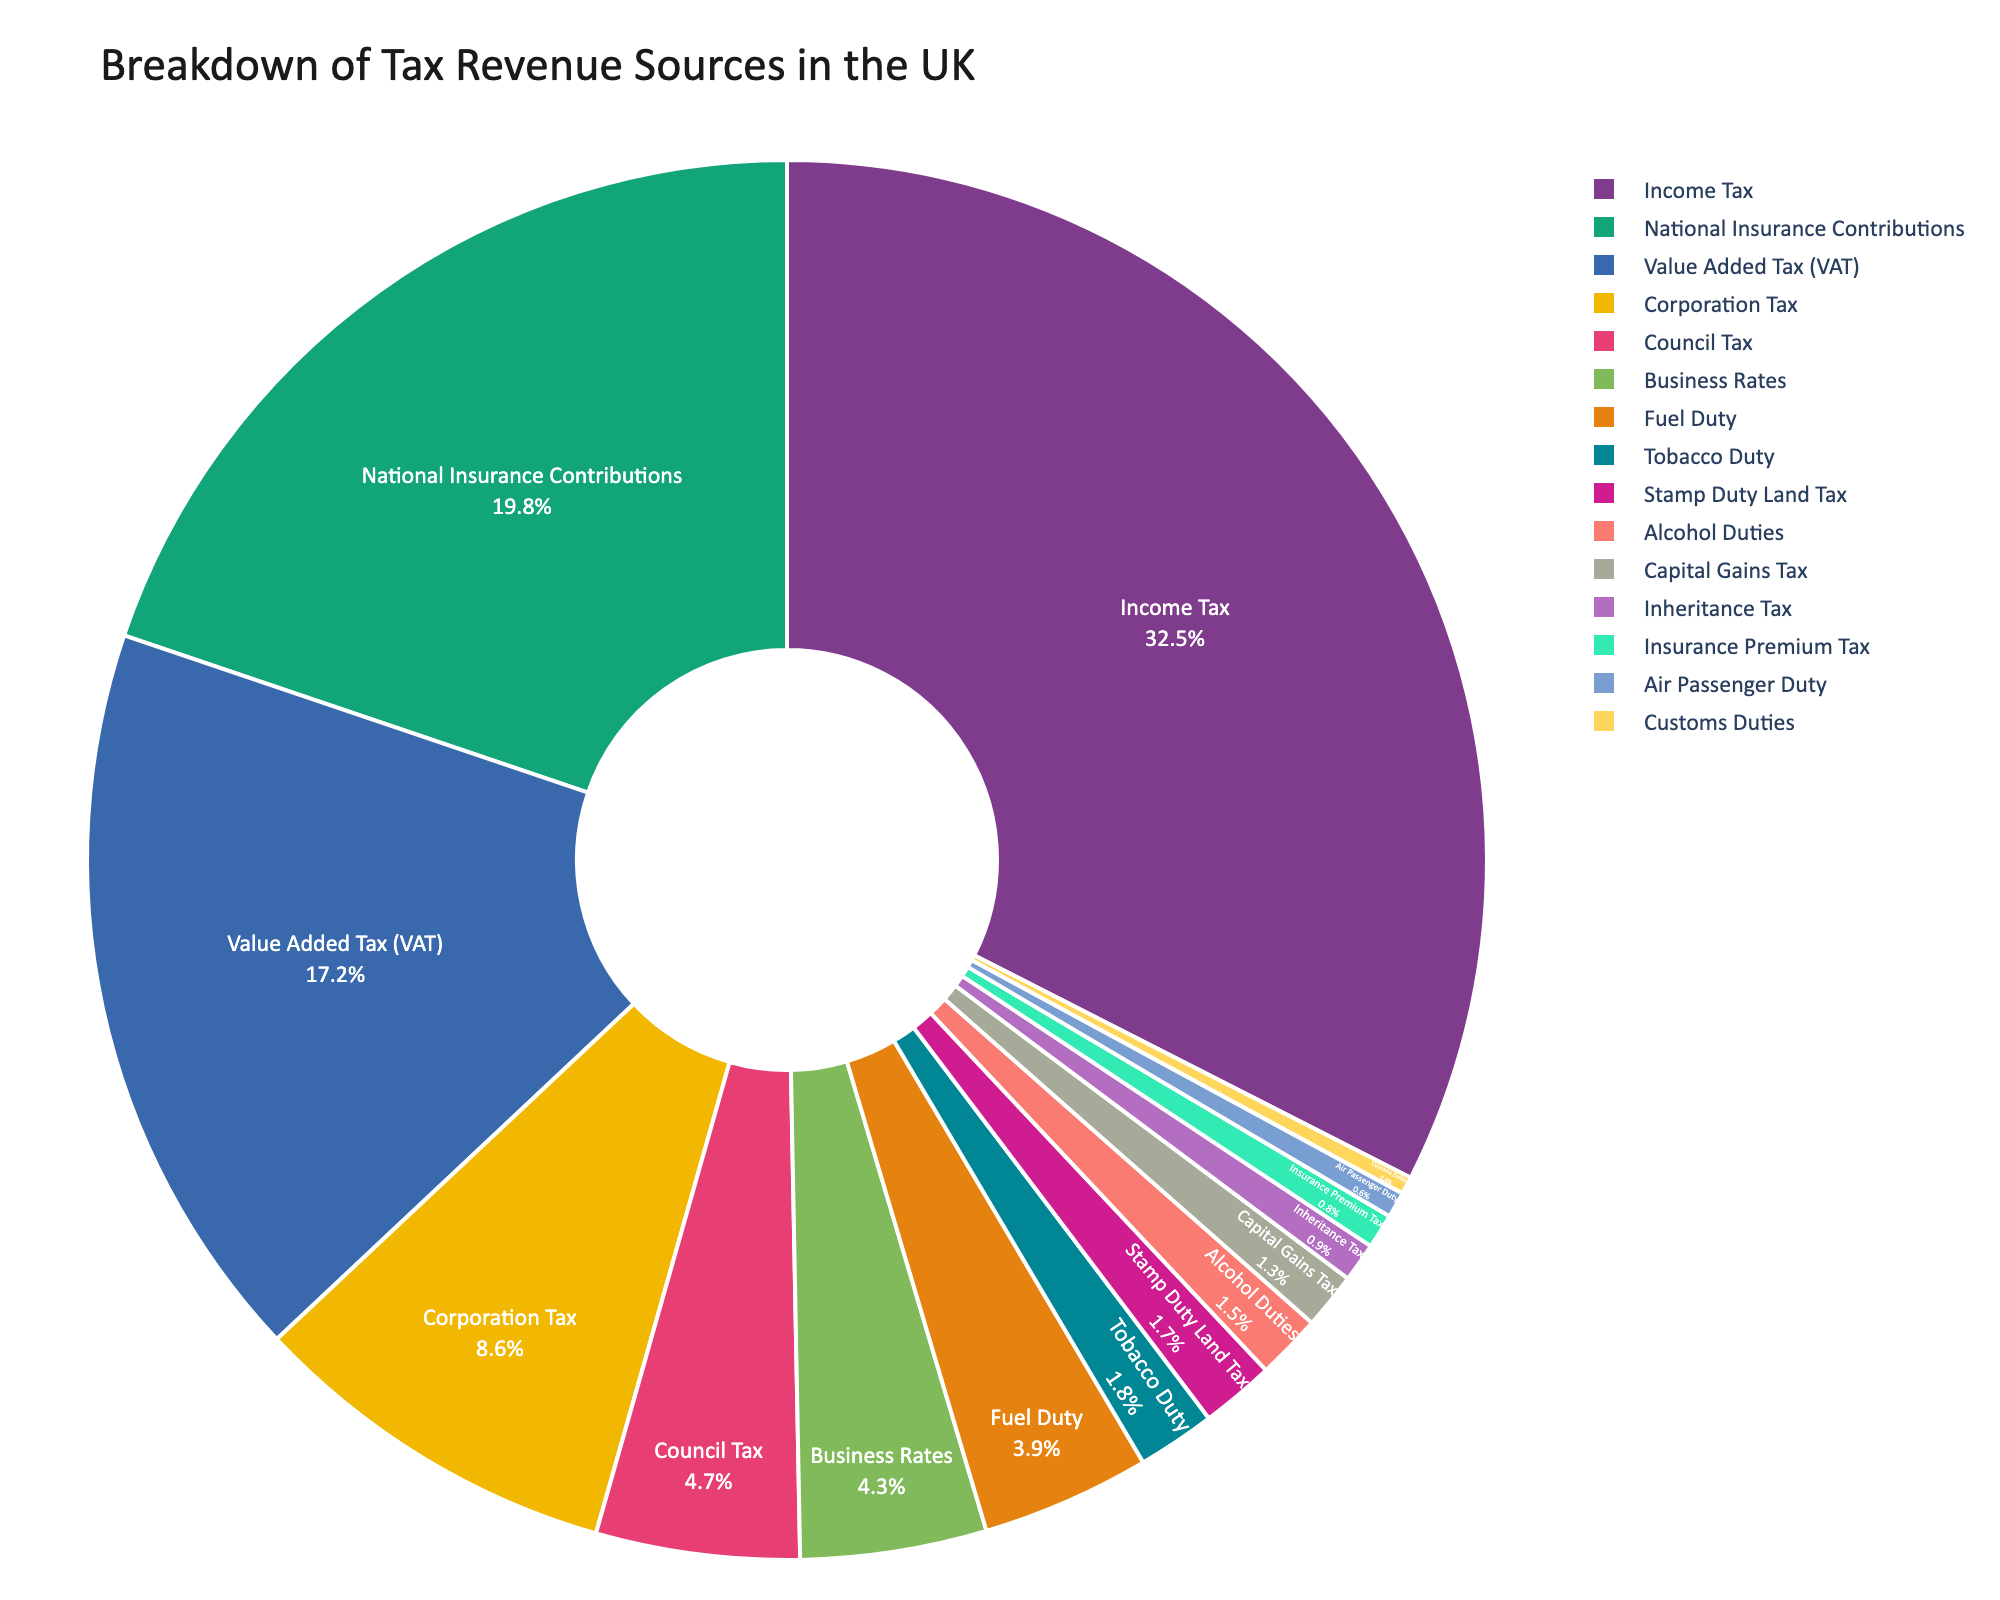What is the largest source of tax revenue in the UK? The largest source of tax revenue can be identified by looking at the segment with the highest percentage on the pie chart. Income Tax has the highest percentage at 32.5%.
Answer: Income Tax What is the combined percentage of tax revenue from Value Added Tax (VAT) and Corporation Tax? To find this, sum the individual percentages of VAT and Corporation Tax. VAT is 17.2% and Corporation Tax is 8.6%. So, 17.2% + 8.6% = 25.8%.
Answer: 25.8% Which tax source contributes more to the revenue, Council Tax or Business Rates? Compare the percentages for Council Tax and Business Rates. Council Tax is 4.7% and Business Rates is 4.3%. Since 4.7% > 4.3%, Council Tax contributes more.
Answer: Council Tax How much greater is the percentage of revenue from National Insurance Contributions compared to Capital Gains Tax? Subtract the percentage for Capital Gains Tax from that of National Insurance Contributions. National Insurance Contributions is 19.8% and Capital Gains Tax is 1.3%. So, 19.8% - 1.3% = 18.5%.
Answer: 18.5% What is the total percentage of tax revenue from Alcohol Duties, Tobacco Duty, Inheritance Tax, and Stamp Duty Land Tax combined? Sum the percentages for Alcohol Duties, Tobacco Duty, Inheritance Tax, and Stamp Duty Land Tax. These are 1.5%, 1.8%, 0.9%, and 1.7% respectively. So, 1.5% + 1.8% + 0.9% + 1.7% = 5.9%.
Answer: 5.9% Which tax sources contribute less than 1% each to the tax revenue? Identify the segments in the pie chart that have percentages less than 1%. These are Inheritance Tax (0.9%) and Customs Duties (0.4%).
Answer: Inheritance Tax, Customs Duties Compare the tax contributions from Fuel Duty and Insurance Premium Tax. Which one is higher and by how much? Fuel Duty is 3.9% and Insurance Premium Tax is 0.8%. Subtract the smaller percentage from the larger one: 3.9% - 0.8% = 3.1%. So, Fuel Duty contributes more, and the difference is 3.1%.
Answer: Fuel Duty by 3.1% What is the median percentage of tax contribution in the given data? To find the median, list all percentages in ascending order and identify the middle value. The percentages are sorted as [0.4, 0.6, 0.8, 0.9, 1.3, 1.5, 1.7, 1.8, 3.9, 4.3, 4.7, 8.6, 17.2, 19.8, 32.5]. The middle value is 1.8%, as it's the 8th value in the list.
Answer: 1.8% What is the visual representation of the tax source with the lowest contribution? The tax source with the lowest contribution will have the smallest segment in the pie chart. Customs Duties is the lowest at 0.4%.
Answer: Customs Duties If you combined the contributions from Air Passenger Duty and Insurance Premium Tax, would they together be greater than Tobacco Duty? First, sum the percentages of Air Passenger Duty (0.6%) and Insurance Premium Tax (0.8%). So, 0.6% + 0.8% = 1.4%. Compare this to Tobacco Duty (1.8%). Since 1.4% < 1.8%, they would not be greater.
Answer: No 